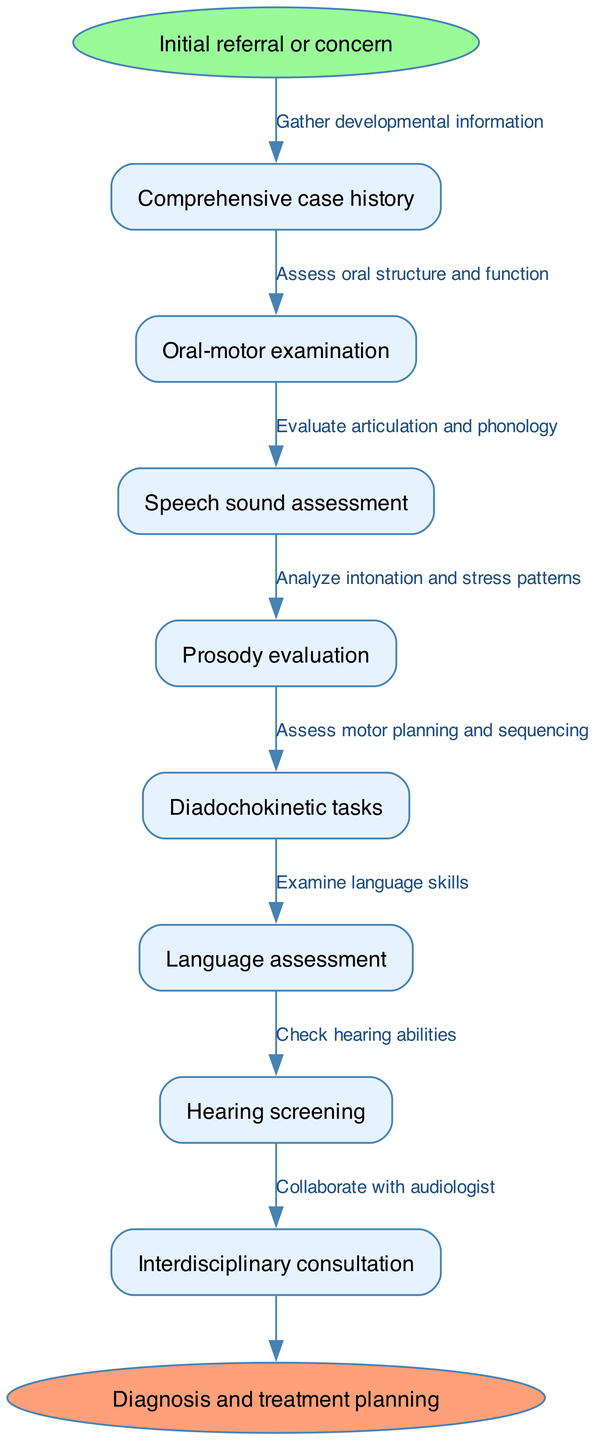What is the starting point of the assessment process? The diagram indicates that the starting point is specified as "Initial referral or concern." This is the first node and is highlighted in an oval shape.
Answer: Initial referral or concern How many nodes are there in the assessment process? Counting the nodes in the diagram, there are a total of 8 nodes, including the starting and ending points.
Answer: 8 What is the last step before the diagnosis and treatment planning? The last process before reaching the diagnosis and treatment planning is "Hearing screening." This is the final node before the end.
Answer: Hearing screening Which node is related to motor planning and sequencing? The node that focuses on motor planning and sequencing is "Diadochokinetic tasks." This node is connected in the flow chart to the sequence of assessments.
Answer: Diadochokinetic tasks What kind of assessments are linked to language skills? The assessment that examines language skills is labeled as "Language assessment." It follows a specific order in the diagram, emphasizing its relevance to language evaluation.
Answer: Language assessment Which two nodes are directly connected to the "Comprehensive case history" node? The "Comprehensive case history" node is directly connected to "Oral-motor examination" and "Speech sound assessment." This shows the initial evaluations conducted after case history.
Answer: Oral-motor examination, Speech sound assessment What is the role of "Interdisciplinary consultation" in the process? "Interdisciplinary consultation" serves as a collaborative effort involving different specialists, in this case, specifically noted in connection with audiology. This step comes towards the end of the assessment flow.
Answer: Collaborate with audiologist How many edges are connecting the nodes in the assessment process? There are a total of 7 edges that connect the nodes in this flow diagram, indicating the relationships between the different steps of the assessment process.
Answer: 7 Which assessment specifically involves intonation and stress patterns? The assessment dedicated to analyzing intonation and stress patterns is labeled "Prosody evaluation," which is essential for understanding speech rhythm and melody.
Answer: Prosody evaluation 